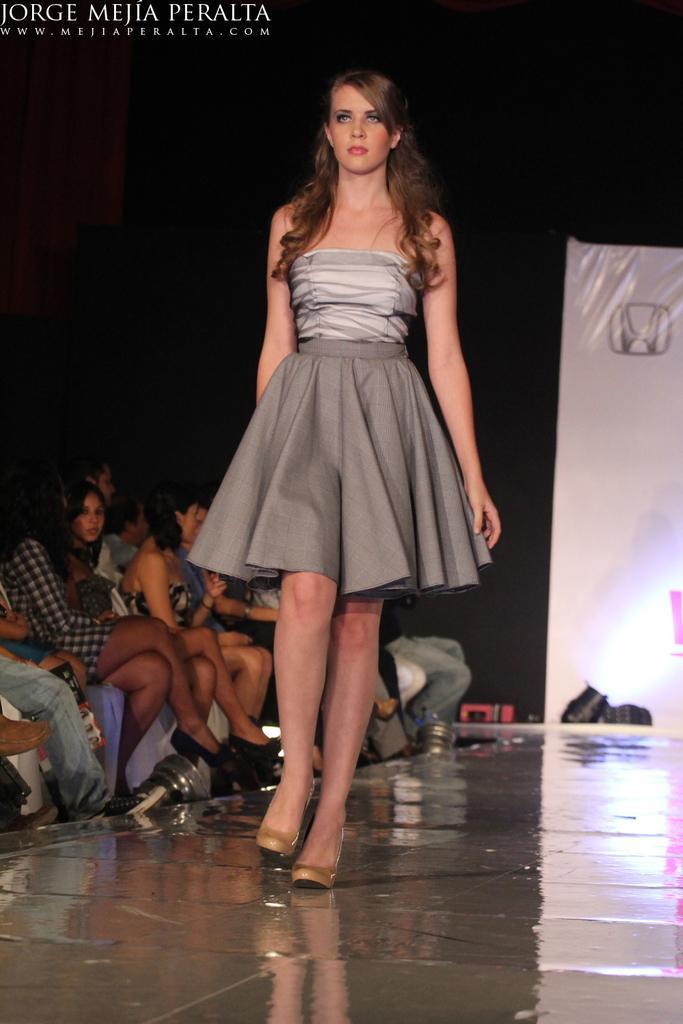Please provide a concise description of this image. This image consists of a woman. She is walking. She is wearing a grey color frock. There are some persons sitting on the left side. There is a banner on the right side. 